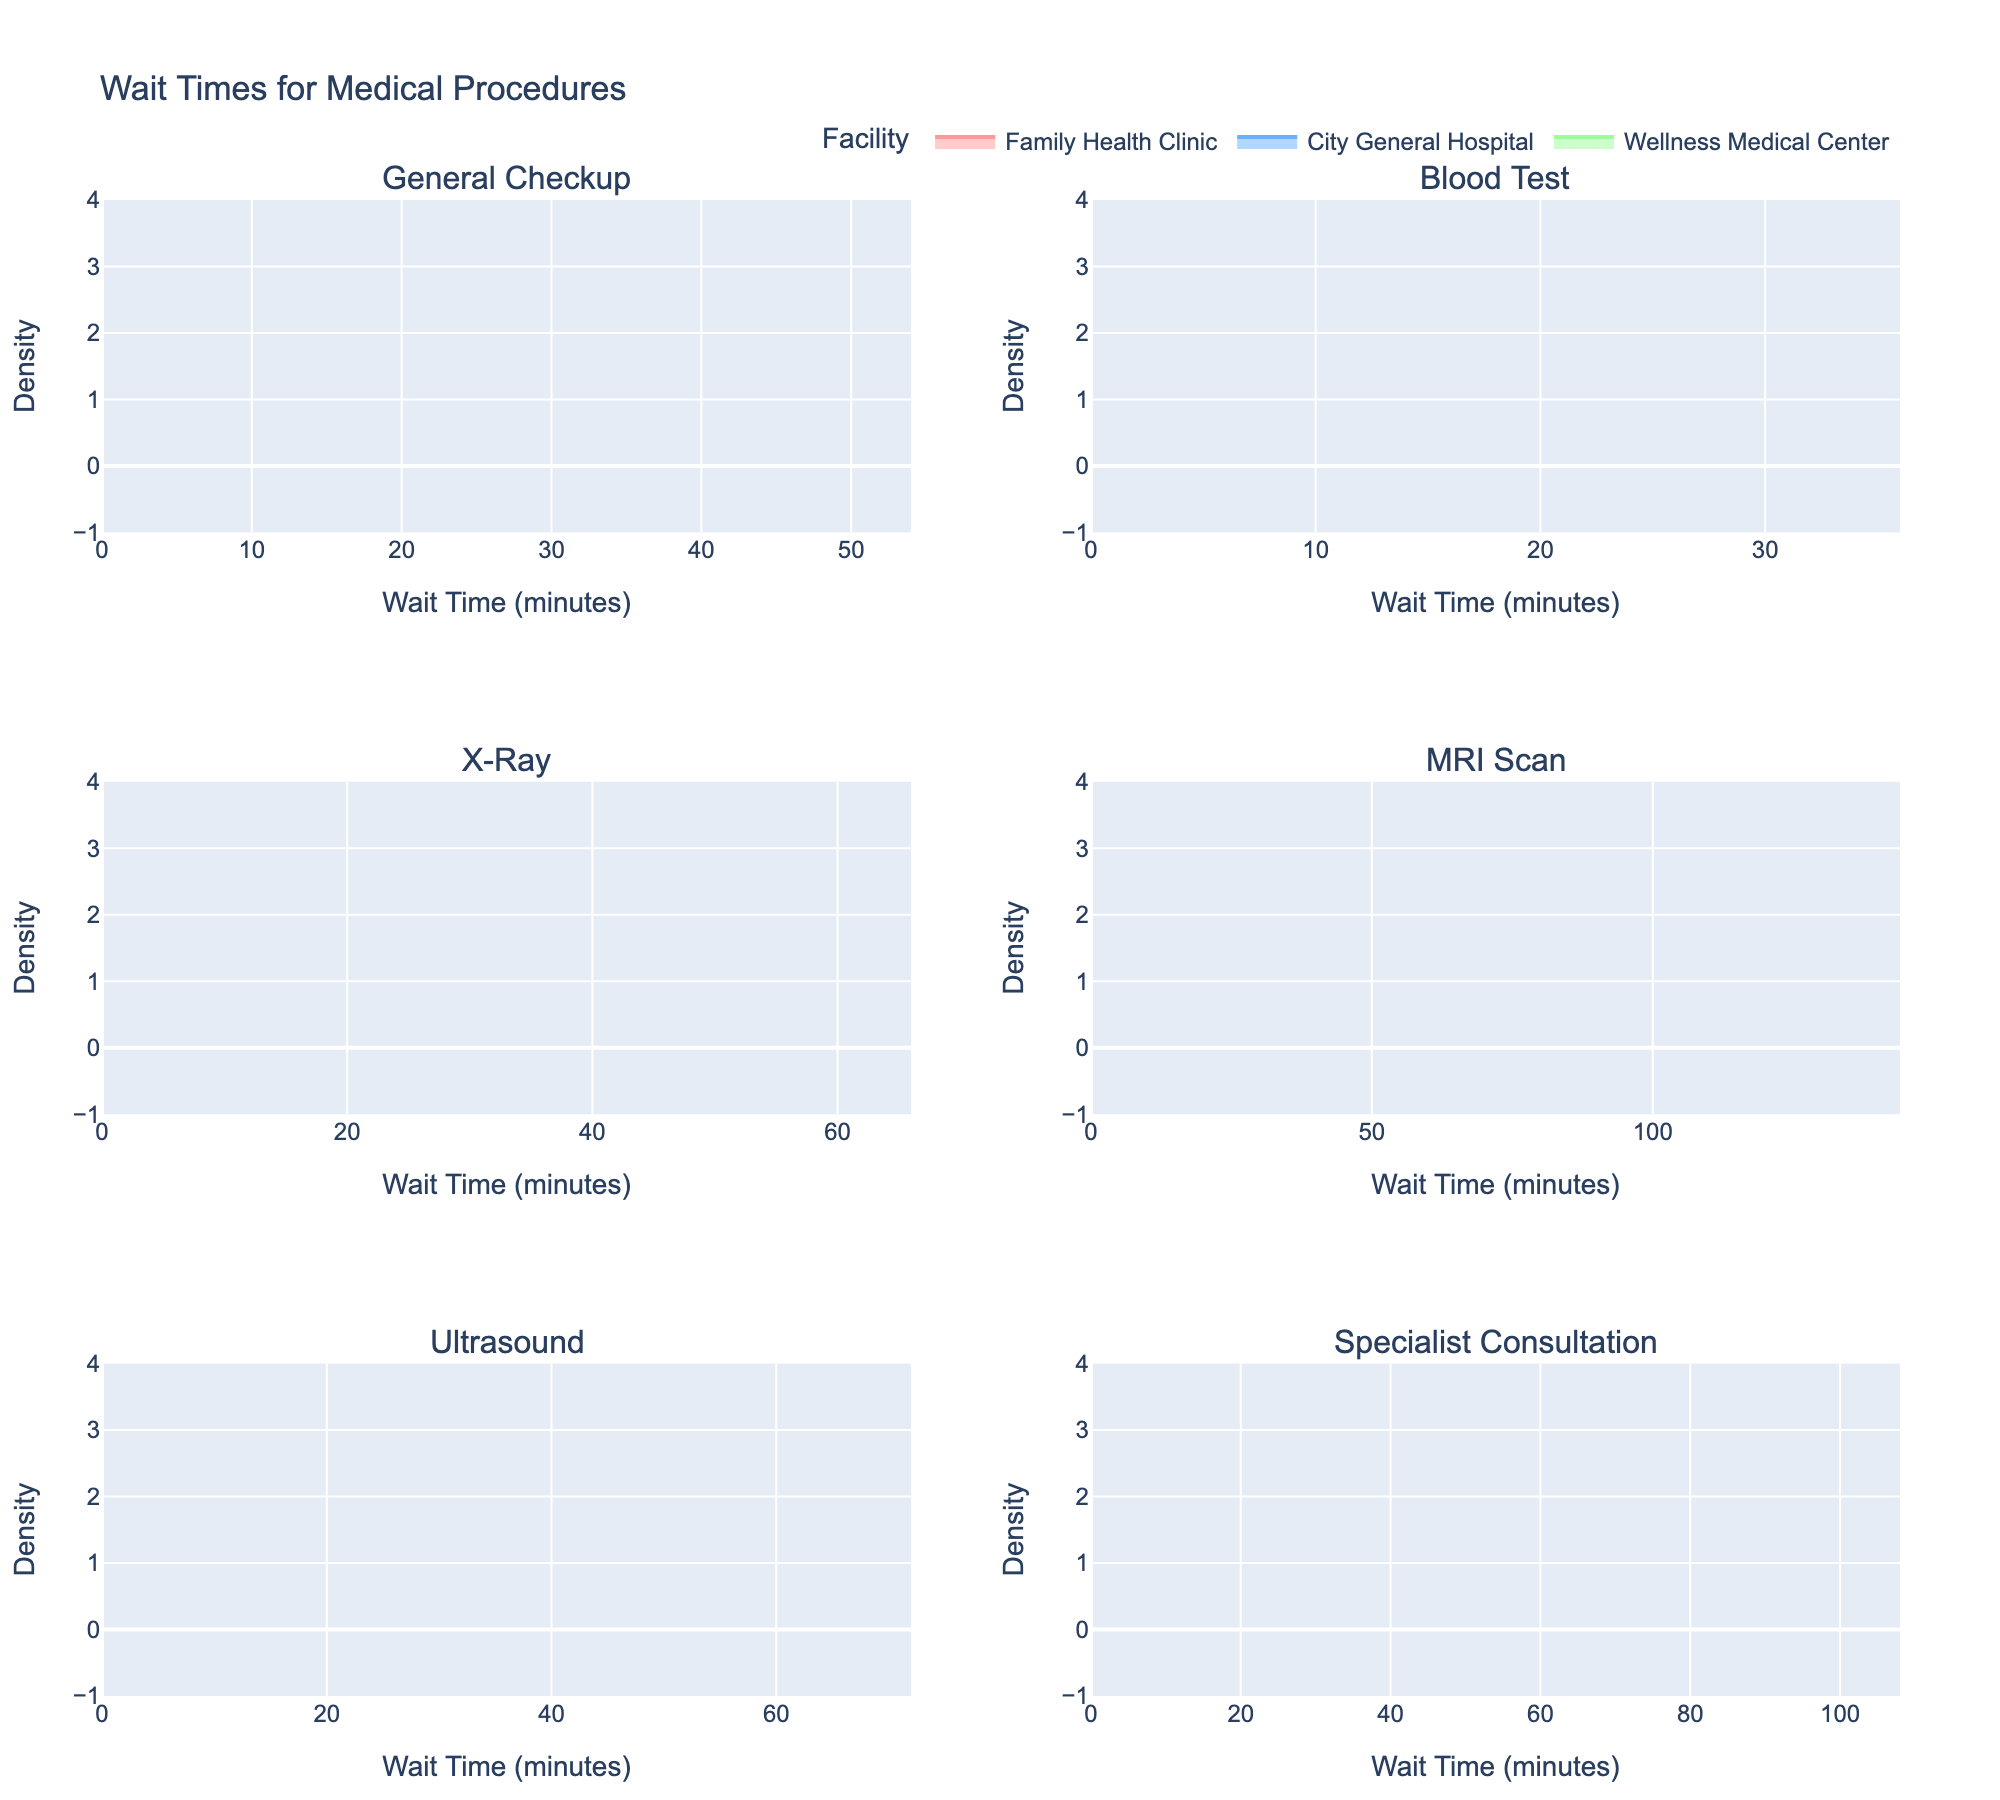Which facility has the shortest wait time for a General Checkup? By looking at the density plot for "General Checkup", we can see that the peak of the density curve for "Family Health Clinic" is at the lowest wait time.
Answer: Family Health Clinic How does the wait time for an MRI Scan at the City General Hospital compare to the Advanced Imaging Center? In the MRI Scan subplot, the density curve for "City General Hospital" peaks at a higher wait time compared to the "Advanced Imaging Center".
Answer: City General Hospital has a longer wait time What is the range of wait times for Blood Tests at Wellness Medical Center? For "Blood Test" at "Wellness Medical Center", the density plot shows wait times extending from around 15 minutes to 20 minutes.
Answer: 15-20 minutes Which procedure has the widest range of wait times? By observing the density plots of all procedures, the MRI Scan appears to have the widest range, with wait times extending from around 90 to 120 minutes.
Answer: MRI Scan Which facility has the longest wait time for an Ultrasound? Within the "Ultrasound" subplot, "City General Hospital" shows the density curve peaking at the highest value.
Answer: City General Hospital How do the wait times for Specialist Consultation compare among the three facilities listed? In the "Specialist Consultation" subplot, "Neurology Partners" has the highest wait time, followed by "Heart & Vascular Institute", and lastly "Orthopedic Excellence Center".
Answer: Neurology Partners > Heart & Vascular Institute > Orthopedic Excellence Center What can you infer about the consistency of wait times for X-Ray at Regional Medical Center? The density plot for "X-Ray" at "Regional Medical Center" is fairly sharp and narrow, suggesting consistent wait times around 55 minutes.
Answer: Consistent around 55 minutes 